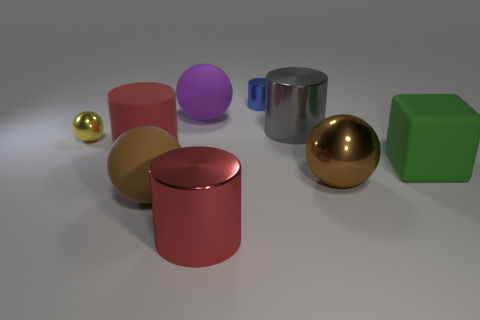Subtract all large cylinders. How many cylinders are left? 1 Subtract all blue balls. Subtract all cyan cylinders. How many balls are left? 4 Subtract all cylinders. How many objects are left? 5 Add 2 blocks. How many blocks are left? 3 Add 1 yellow metal balls. How many yellow metal balls exist? 2 Subtract 1 purple spheres. How many objects are left? 8 Subtract all small blue cylinders. Subtract all small yellow spheres. How many objects are left? 7 